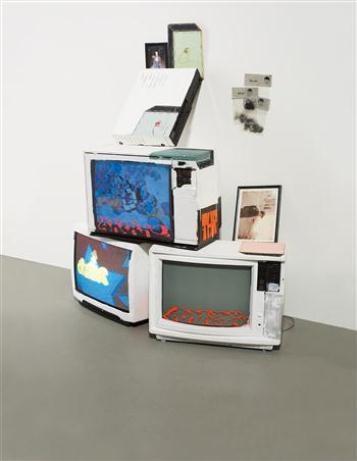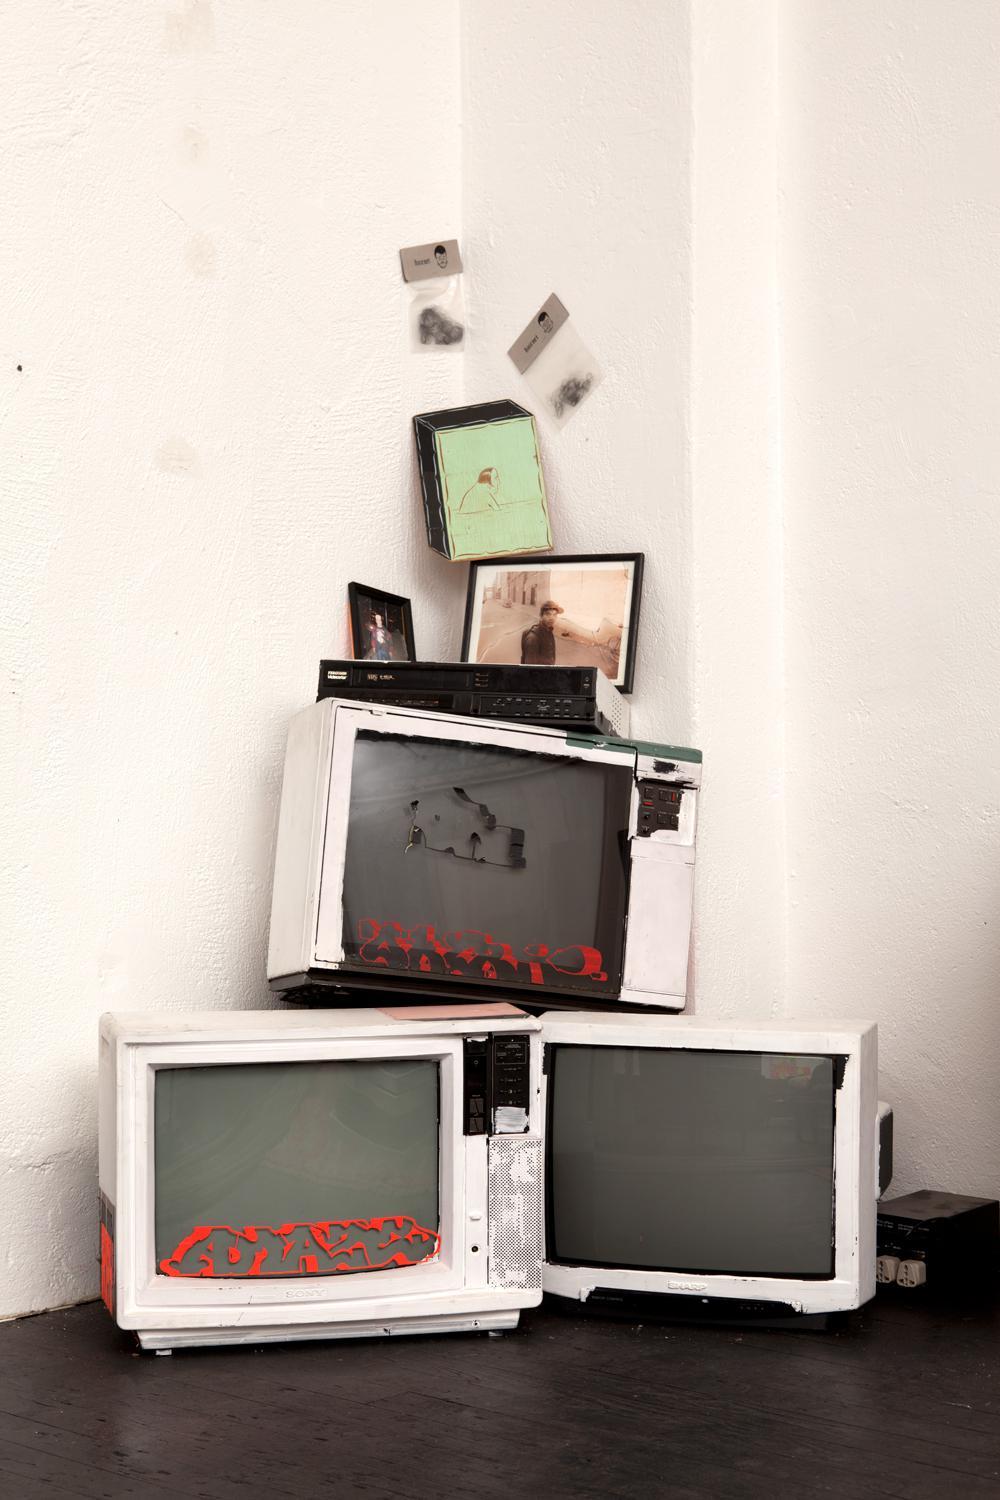The first image is the image on the left, the second image is the image on the right. Given the left and right images, does the statement "In one image, the monitors are stacked in the shape of an animal or person." hold true? Answer yes or no. No. The first image is the image on the left, the second image is the image on the right. For the images shown, is this caption "Both images contain an equal number of monitors." true? Answer yes or no. Yes. The first image is the image on the left, the second image is the image on the right. Assess this claim about the two images: "tv's are stacked in a triangular shape". Correct or not? Answer yes or no. Yes. 